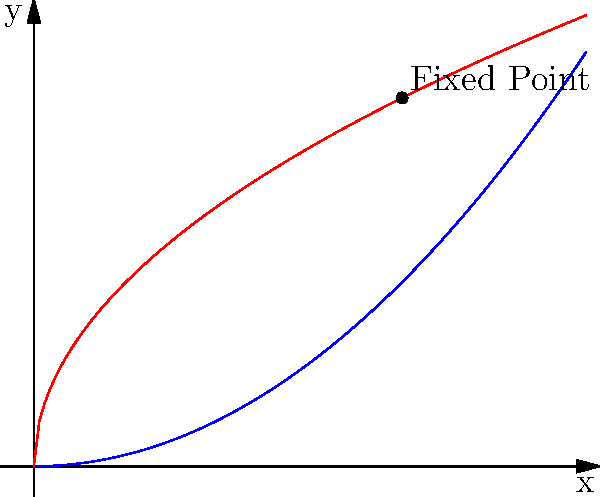In the context of economic equilibria, consider the functions $f(x) = \frac{x^2}{2}$ and $g(x) = \sqrt{x}$ shown in the graph. What theorem guarantees the existence of a fixed point where these functions intersect, and how does this relate to proving the existence of economic equilibria? 1. The graph shows two functions intersecting at the point (1,1), which is a fixed point.

2. The theorem that guarantees the existence of this fixed point is Brouwer's Fixed-Point Theorem. It states that for any continuous function $f$ mapping a compact convex set to itself, there exists a point $x$ such that $f(x) = x$.

3. In this case, we can consider the function $h(x) = g(f(x))$ mapping $[0,1]$ to itself. Brouwer's theorem guarantees a fixed point for this composition.

4. In economics, this theorem is crucial for proving the existence of equilibria:
   a) Economic models often involve continuous functions mapping a set of possible states to itself.
   b) The fixed point represents an equilibrium where no agent has an incentive to change their behavior.

5. For example, in a simple supply-demand model:
   a) The supply function $S(p)$ and demand function $D(p)$ are continuous.
   b) The equilibrium price $p^*$ satisfies $S(p^*) = D(p^*)$, which is a fixed point.

6. More complex models, like general equilibrium theory, use generalizations of Brouwer's theorem (e.g., Kakutani's fixed-point theorem) to prove the existence of equilibria in multi-dimensional spaces.

7. The fixed-point approach allows economists to prove the existence of equilibria without explicitly solving for them, which is often impossible in complex models.
Answer: Brouwer's Fixed-Point Theorem; guarantees equilibrium existence in continuous economic models. 